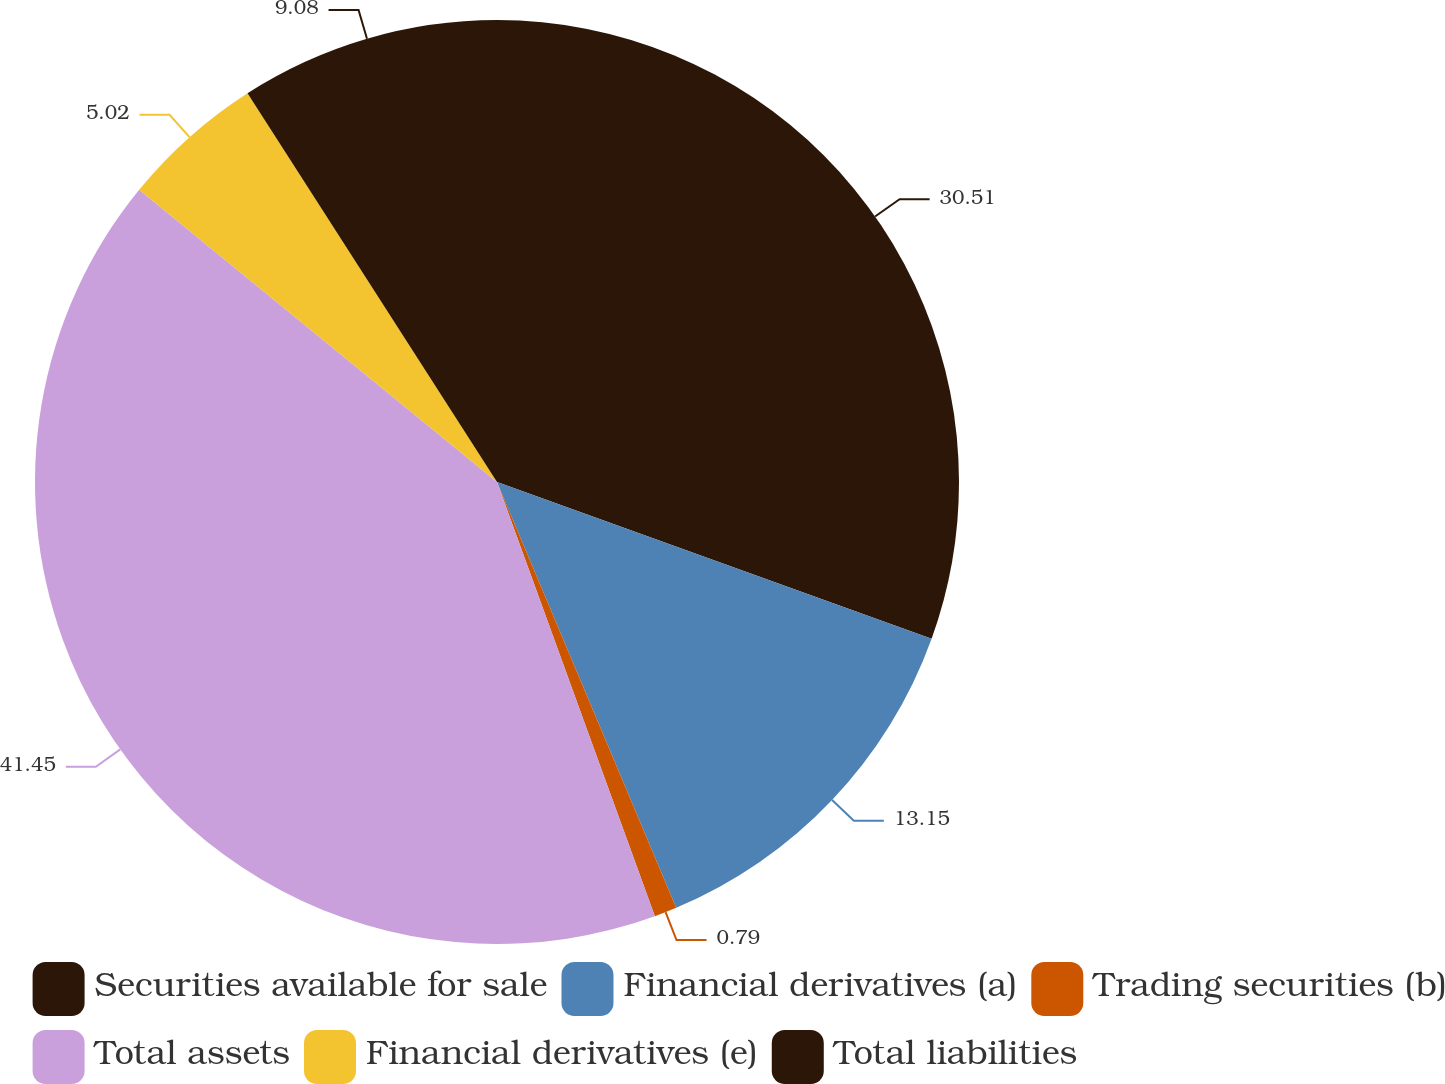Convert chart. <chart><loc_0><loc_0><loc_500><loc_500><pie_chart><fcel>Securities available for sale<fcel>Financial derivatives (a)<fcel>Trading securities (b)<fcel>Total assets<fcel>Financial derivatives (e)<fcel>Total liabilities<nl><fcel>30.51%<fcel>13.15%<fcel>0.79%<fcel>41.45%<fcel>5.02%<fcel>9.08%<nl></chart> 